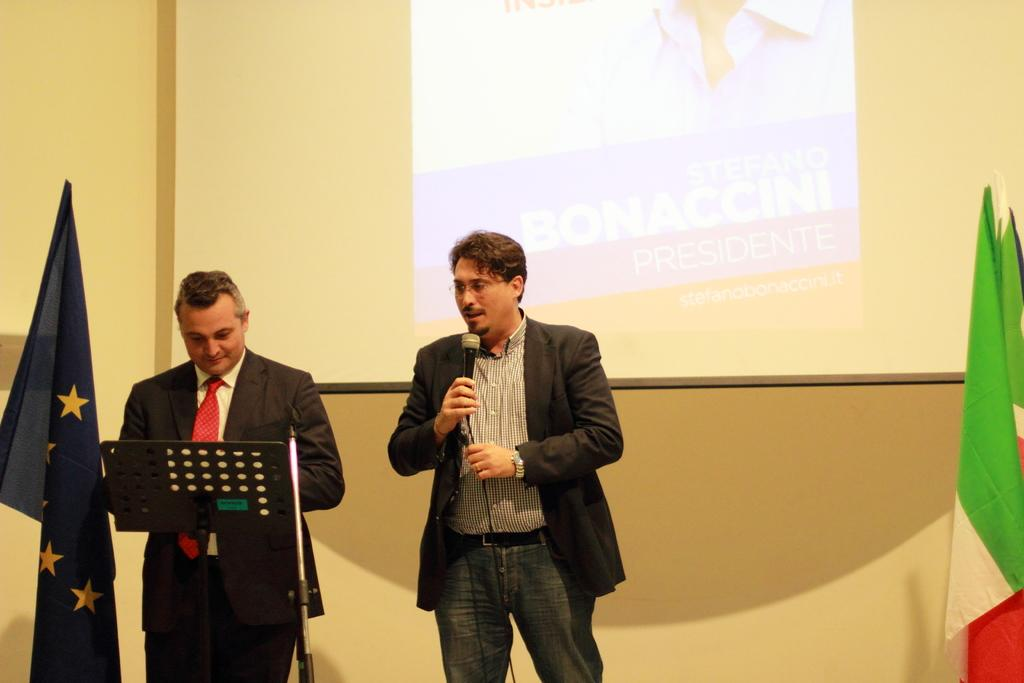How many people are in the image? There are two people in the image. What are the people wearing? Both people are wearing black suits. What is one of the people holding? One of the people is holding a microphone. What can be seen behind the people? There is a screen behind the people. What is located beside the people? There are two flags beside the people. What type of sail can be seen on the airplane in the image? There is no airplane or sail present in the image. How many clocks are visible on the screen behind the people? There is no information about clocks or the content of the screen in the provided facts. 